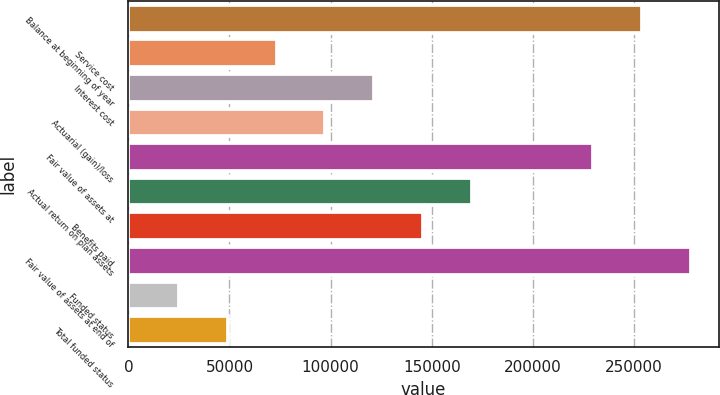<chart> <loc_0><loc_0><loc_500><loc_500><bar_chart><fcel>Balance at beginning of year<fcel>Service cost<fcel>Interest cost<fcel>Actuarial (gain)/loss<fcel>Fair value of assets at<fcel>Actual return on plan assets<fcel>Benefits paid<fcel>Fair value of assets at end of<fcel>Funded status<fcel>Total funded status<nl><fcel>253923<fcel>73319.4<fcel>121555<fcel>97437.2<fcel>229805<fcel>169791<fcel>145673<fcel>278041<fcel>25083.8<fcel>49201.6<nl></chart> 